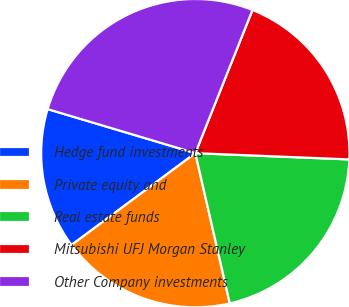<chart> <loc_0><loc_0><loc_500><loc_500><pie_chart><fcel>Hedge fund investments<fcel>Private equity and<fcel>Real estate funds<fcel>Mitsubishi UFJ Morgan Stanley<fcel>Other Company investments<nl><fcel>14.77%<fcel>18.43%<fcel>20.76%<fcel>19.6%<fcel>26.43%<nl></chart> 